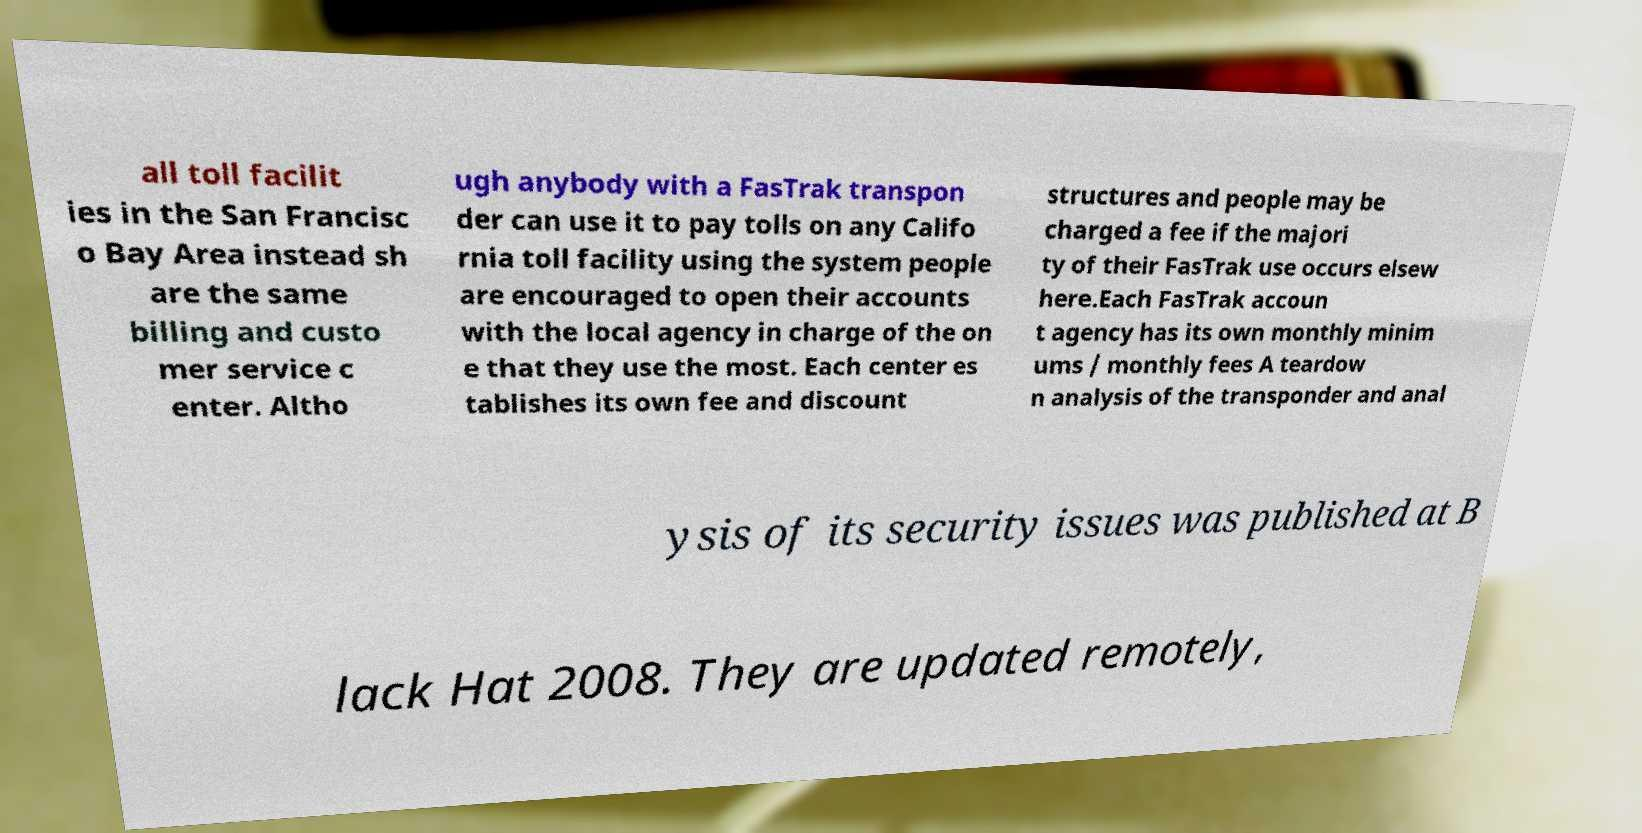Can you read and provide the text displayed in the image?This photo seems to have some interesting text. Can you extract and type it out for me? all toll facilit ies in the San Francisc o Bay Area instead sh are the same billing and custo mer service c enter. Altho ugh anybody with a FasTrak transpon der can use it to pay tolls on any Califo rnia toll facility using the system people are encouraged to open their accounts with the local agency in charge of the on e that they use the most. Each center es tablishes its own fee and discount structures and people may be charged a fee if the majori ty of their FasTrak use occurs elsew here.Each FasTrak accoun t agency has its own monthly minim ums / monthly fees A teardow n analysis of the transponder and anal ysis of its security issues was published at B lack Hat 2008. They are updated remotely, 